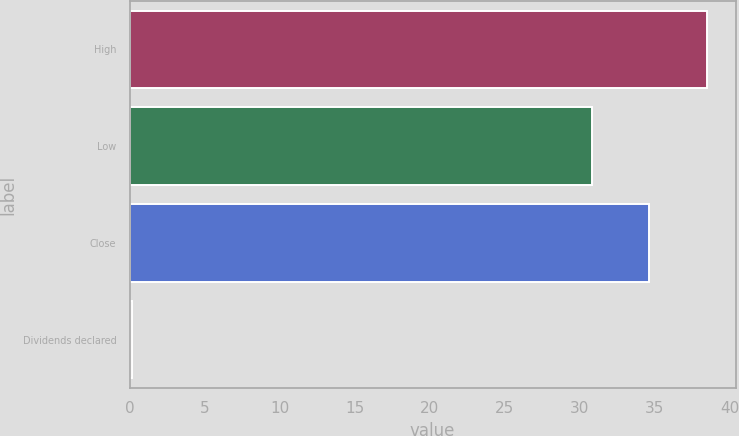Convert chart. <chart><loc_0><loc_0><loc_500><loc_500><bar_chart><fcel>High<fcel>Low<fcel>Close<fcel>Dividends declared<nl><fcel>38.46<fcel>30.8<fcel>34.63<fcel>0.13<nl></chart> 